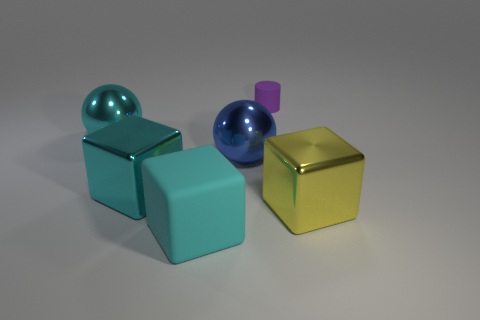Add 2 cyan blocks. How many objects exist? 8 Subtract all spheres. How many objects are left? 4 Subtract all large cyan metallic objects. Subtract all big spheres. How many objects are left? 2 Add 1 blue spheres. How many blue spheres are left? 2 Add 1 small blue shiny things. How many small blue shiny things exist? 1 Subtract 1 purple cylinders. How many objects are left? 5 